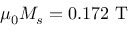Convert formula to latex. <formula><loc_0><loc_0><loc_500><loc_500>\mu _ { 0 } M _ { s } = 0 . 1 7 2 T</formula> 